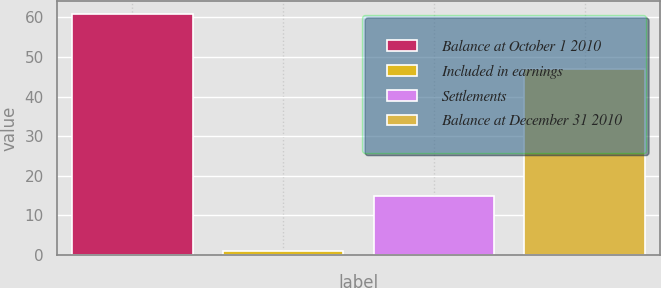Convert chart to OTSL. <chart><loc_0><loc_0><loc_500><loc_500><bar_chart><fcel>Balance at October 1 2010<fcel>Included in earnings<fcel>Settlements<fcel>Balance at December 31 2010<nl><fcel>61<fcel>1<fcel>15<fcel>47<nl></chart> 